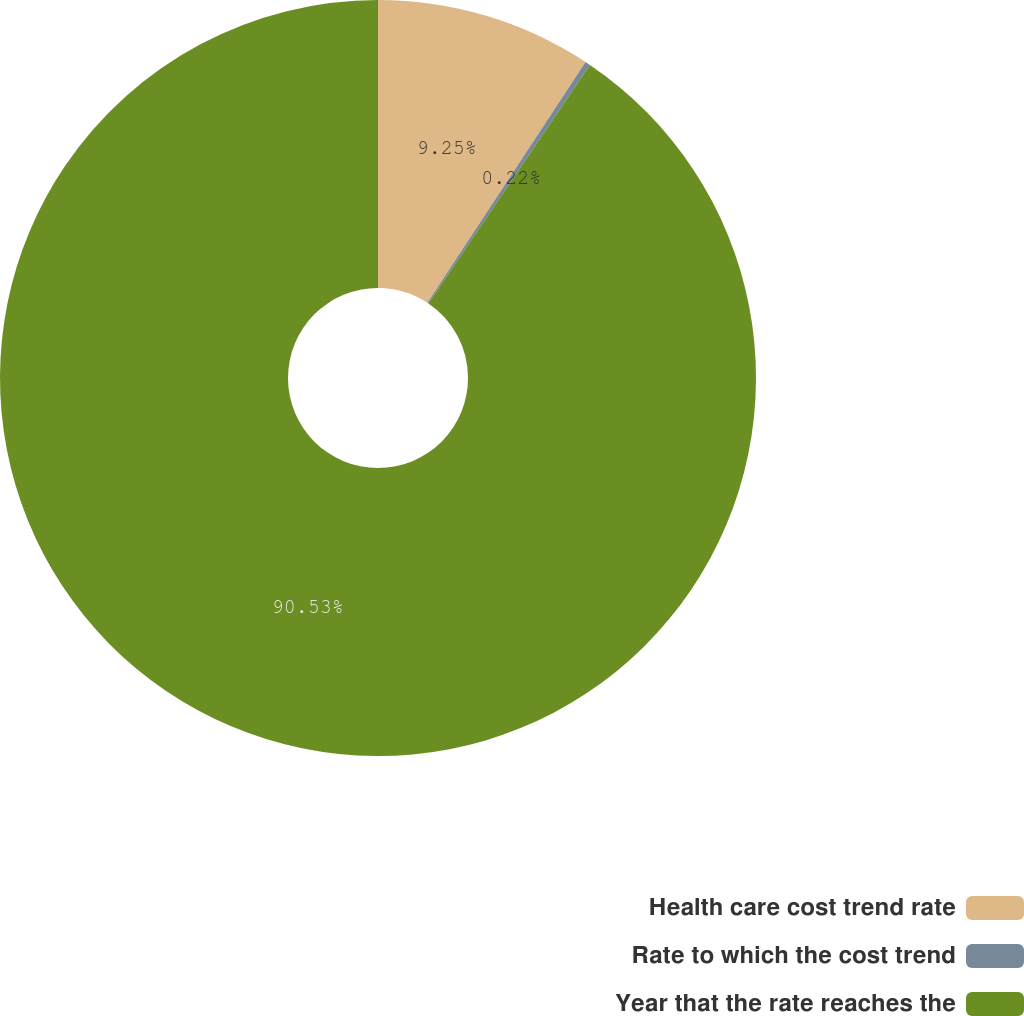Convert chart to OTSL. <chart><loc_0><loc_0><loc_500><loc_500><pie_chart><fcel>Health care cost trend rate<fcel>Rate to which the cost trend<fcel>Year that the rate reaches the<nl><fcel>9.25%<fcel>0.22%<fcel>90.52%<nl></chart> 